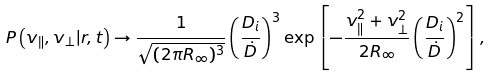<formula> <loc_0><loc_0><loc_500><loc_500>P \left ( v _ { \| } , v _ { \perp } | r , t \right ) \rightarrow \frac { 1 } { \sqrt { ( 2 \pi R _ { \infty } ) ^ { 3 } } } \left ( \frac { D _ { i } } { \dot { D } } \right ) ^ { 3 } \exp \left [ - \frac { v _ { \| } ^ { 2 } + v _ { \perp } ^ { 2 } } { 2 R _ { \infty } } \left ( \frac { D _ { i } } { \dot { D } } \right ) ^ { 2 } \right ] ,</formula> 